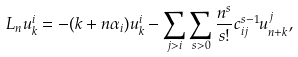Convert formula to latex. <formula><loc_0><loc_0><loc_500><loc_500>L _ { n } u ^ { i } _ { k } = - ( k + n \alpha _ { i } ) u ^ { i } _ { k } - \sum _ { j > i } \sum _ { s > 0 } \frac { n ^ { s } } { s ! } c _ { i j } ^ { s - 1 } u ^ { j } _ { n + k } ,</formula> 